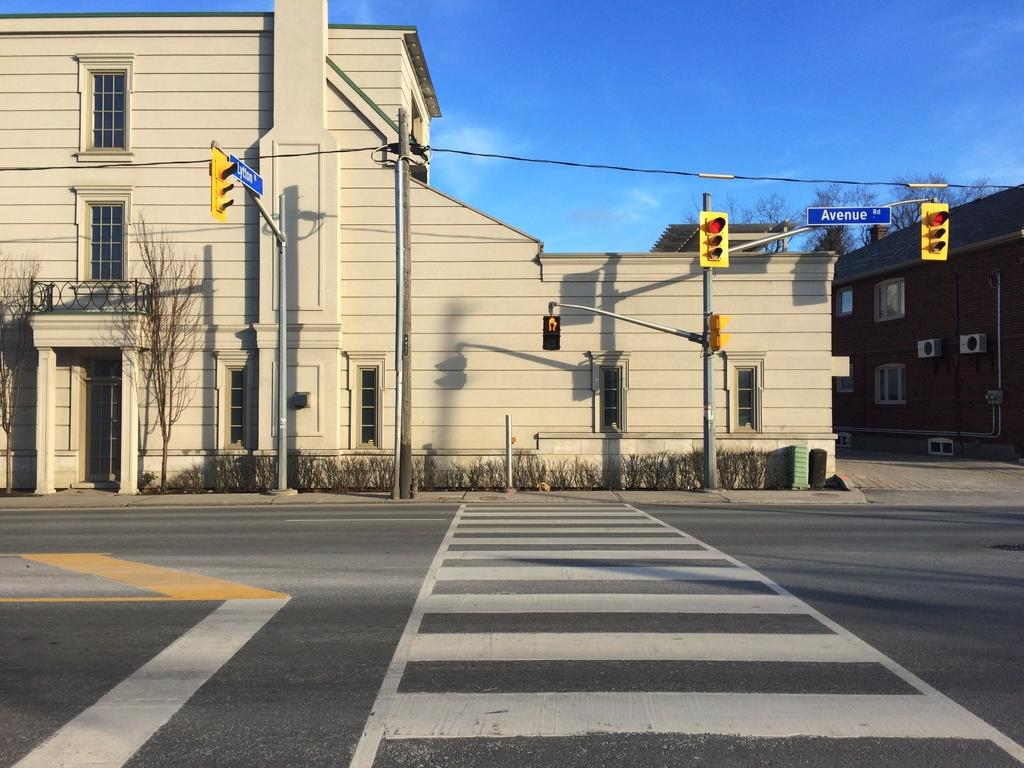<image>
Summarize the visual content of the image. A crossroads and traffic lights at Avenue Road. 